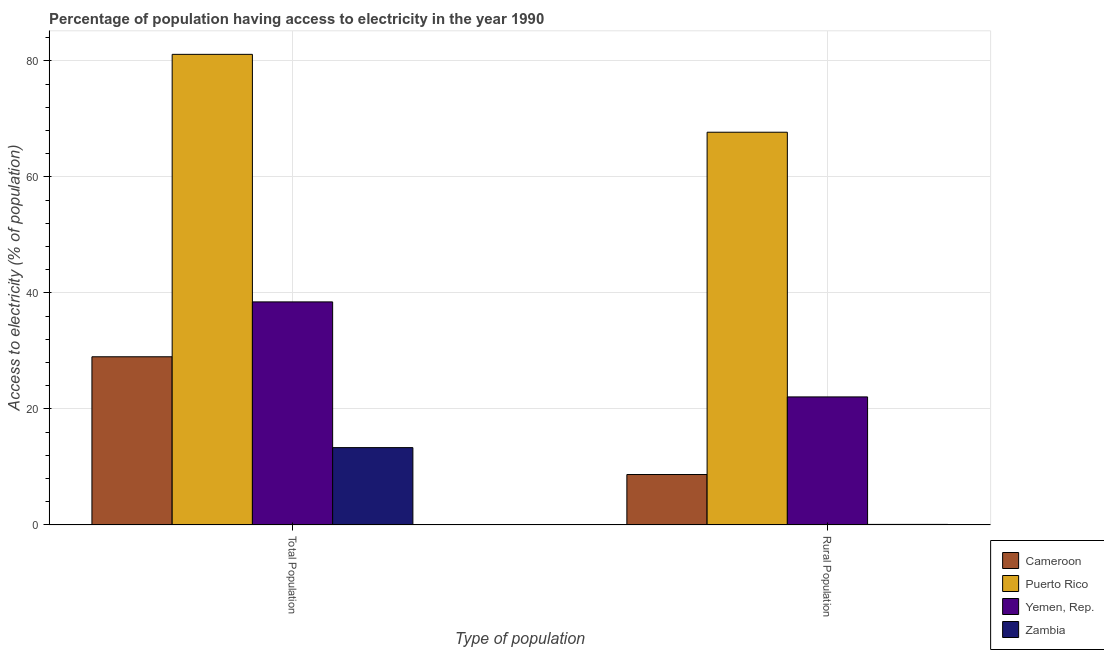Are the number of bars per tick equal to the number of legend labels?
Your response must be concise. Yes. How many bars are there on the 2nd tick from the left?
Offer a terse response. 4. What is the label of the 2nd group of bars from the left?
Offer a very short reply. Rural Population. What is the percentage of rural population having access to electricity in Yemen, Rep.?
Your response must be concise. 22.08. Across all countries, what is the maximum percentage of rural population having access to electricity?
Offer a very short reply. 67.71. Across all countries, what is the minimum percentage of rural population having access to electricity?
Offer a very short reply. 0.1. In which country was the percentage of population having access to electricity maximum?
Keep it short and to the point. Puerto Rico. In which country was the percentage of rural population having access to electricity minimum?
Keep it short and to the point. Zambia. What is the total percentage of rural population having access to electricity in the graph?
Provide a succinct answer. 98.59. What is the difference between the percentage of population having access to electricity in Yemen, Rep. and that in Puerto Rico?
Provide a succinct answer. -42.68. What is the difference between the percentage of population having access to electricity in Cameroon and the percentage of rural population having access to electricity in Puerto Rico?
Your answer should be compact. -38.71. What is the average percentage of rural population having access to electricity per country?
Your answer should be compact. 24.65. What is the difference between the percentage of population having access to electricity and percentage of rural population having access to electricity in Cameroon?
Provide a succinct answer. 20.3. What is the ratio of the percentage of rural population having access to electricity in Puerto Rico to that in Cameroon?
Your answer should be very brief. 7.78. In how many countries, is the percentage of rural population having access to electricity greater than the average percentage of rural population having access to electricity taken over all countries?
Give a very brief answer. 1. What does the 3rd bar from the left in Total Population represents?
Your answer should be compact. Yemen, Rep. What does the 3rd bar from the right in Rural Population represents?
Your answer should be compact. Puerto Rico. Are the values on the major ticks of Y-axis written in scientific E-notation?
Your answer should be very brief. No. Does the graph contain any zero values?
Provide a short and direct response. No. Does the graph contain grids?
Ensure brevity in your answer.  Yes. What is the title of the graph?
Give a very brief answer. Percentage of population having access to electricity in the year 1990. What is the label or title of the X-axis?
Your answer should be very brief. Type of population. What is the label or title of the Y-axis?
Provide a succinct answer. Access to electricity (% of population). What is the Access to electricity (% of population) of Cameroon in Total Population?
Make the answer very short. 29. What is the Access to electricity (% of population) in Puerto Rico in Total Population?
Your response must be concise. 81.14. What is the Access to electricity (% of population) of Yemen, Rep. in Total Population?
Ensure brevity in your answer.  38.46. What is the Access to electricity (% of population) in Zambia in Total Population?
Provide a short and direct response. 13.34. What is the Access to electricity (% of population) in Puerto Rico in Rural Population?
Offer a very short reply. 67.71. What is the Access to electricity (% of population) of Yemen, Rep. in Rural Population?
Your response must be concise. 22.08. Across all Type of population, what is the maximum Access to electricity (% of population) of Puerto Rico?
Your response must be concise. 81.14. Across all Type of population, what is the maximum Access to electricity (% of population) of Yemen, Rep.?
Keep it short and to the point. 38.46. Across all Type of population, what is the maximum Access to electricity (% of population) of Zambia?
Offer a very short reply. 13.34. Across all Type of population, what is the minimum Access to electricity (% of population) in Cameroon?
Provide a short and direct response. 8.7. Across all Type of population, what is the minimum Access to electricity (% of population) of Puerto Rico?
Offer a terse response. 67.71. Across all Type of population, what is the minimum Access to electricity (% of population) in Yemen, Rep.?
Ensure brevity in your answer.  22.08. What is the total Access to electricity (% of population) of Cameroon in the graph?
Provide a short and direct response. 37.7. What is the total Access to electricity (% of population) in Puerto Rico in the graph?
Give a very brief answer. 148.85. What is the total Access to electricity (% of population) of Yemen, Rep. in the graph?
Your answer should be very brief. 60.54. What is the total Access to electricity (% of population) in Zambia in the graph?
Make the answer very short. 13.44. What is the difference between the Access to electricity (% of population) of Cameroon in Total Population and that in Rural Population?
Ensure brevity in your answer.  20.3. What is the difference between the Access to electricity (% of population) in Puerto Rico in Total Population and that in Rural Population?
Offer a very short reply. 13.42. What is the difference between the Access to electricity (% of population) of Yemen, Rep. in Total Population and that in Rural Population?
Ensure brevity in your answer.  16.38. What is the difference between the Access to electricity (% of population) of Zambia in Total Population and that in Rural Population?
Your answer should be compact. 13.24. What is the difference between the Access to electricity (% of population) in Cameroon in Total Population and the Access to electricity (% of population) in Puerto Rico in Rural Population?
Keep it short and to the point. -38.71. What is the difference between the Access to electricity (% of population) in Cameroon in Total Population and the Access to electricity (% of population) in Yemen, Rep. in Rural Population?
Ensure brevity in your answer.  6.92. What is the difference between the Access to electricity (% of population) in Cameroon in Total Population and the Access to electricity (% of population) in Zambia in Rural Population?
Provide a succinct answer. 28.9. What is the difference between the Access to electricity (% of population) in Puerto Rico in Total Population and the Access to electricity (% of population) in Yemen, Rep. in Rural Population?
Provide a short and direct response. 59.06. What is the difference between the Access to electricity (% of population) in Puerto Rico in Total Population and the Access to electricity (% of population) in Zambia in Rural Population?
Provide a short and direct response. 81.04. What is the difference between the Access to electricity (% of population) in Yemen, Rep. in Total Population and the Access to electricity (% of population) in Zambia in Rural Population?
Offer a very short reply. 38.36. What is the average Access to electricity (% of population) in Cameroon per Type of population?
Give a very brief answer. 18.85. What is the average Access to electricity (% of population) in Puerto Rico per Type of population?
Provide a short and direct response. 74.42. What is the average Access to electricity (% of population) in Yemen, Rep. per Type of population?
Provide a succinct answer. 30.27. What is the average Access to electricity (% of population) of Zambia per Type of population?
Provide a short and direct response. 6.72. What is the difference between the Access to electricity (% of population) in Cameroon and Access to electricity (% of population) in Puerto Rico in Total Population?
Ensure brevity in your answer.  -52.14. What is the difference between the Access to electricity (% of population) in Cameroon and Access to electricity (% of population) in Yemen, Rep. in Total Population?
Your response must be concise. -9.46. What is the difference between the Access to electricity (% of population) of Cameroon and Access to electricity (% of population) of Zambia in Total Population?
Provide a short and direct response. 15.66. What is the difference between the Access to electricity (% of population) of Puerto Rico and Access to electricity (% of population) of Yemen, Rep. in Total Population?
Provide a short and direct response. 42.68. What is the difference between the Access to electricity (% of population) in Puerto Rico and Access to electricity (% of population) in Zambia in Total Population?
Make the answer very short. 67.8. What is the difference between the Access to electricity (% of population) in Yemen, Rep. and Access to electricity (% of population) in Zambia in Total Population?
Your answer should be very brief. 25.12. What is the difference between the Access to electricity (% of population) in Cameroon and Access to electricity (% of population) in Puerto Rico in Rural Population?
Ensure brevity in your answer.  -59.01. What is the difference between the Access to electricity (% of population) in Cameroon and Access to electricity (% of population) in Yemen, Rep. in Rural Population?
Your response must be concise. -13.38. What is the difference between the Access to electricity (% of population) in Cameroon and Access to electricity (% of population) in Zambia in Rural Population?
Offer a terse response. 8.6. What is the difference between the Access to electricity (% of population) of Puerto Rico and Access to electricity (% of population) of Yemen, Rep. in Rural Population?
Your answer should be compact. 45.63. What is the difference between the Access to electricity (% of population) in Puerto Rico and Access to electricity (% of population) in Zambia in Rural Population?
Ensure brevity in your answer.  67.61. What is the difference between the Access to electricity (% of population) in Yemen, Rep. and Access to electricity (% of population) in Zambia in Rural Population?
Offer a terse response. 21.98. What is the ratio of the Access to electricity (% of population) of Puerto Rico in Total Population to that in Rural Population?
Provide a succinct answer. 1.2. What is the ratio of the Access to electricity (% of population) in Yemen, Rep. in Total Population to that in Rural Population?
Keep it short and to the point. 1.74. What is the ratio of the Access to electricity (% of population) in Zambia in Total Population to that in Rural Population?
Provide a succinct answer. 133.38. What is the difference between the highest and the second highest Access to electricity (% of population) in Cameroon?
Your answer should be compact. 20.3. What is the difference between the highest and the second highest Access to electricity (% of population) of Puerto Rico?
Ensure brevity in your answer.  13.42. What is the difference between the highest and the second highest Access to electricity (% of population) of Yemen, Rep.?
Your response must be concise. 16.38. What is the difference between the highest and the second highest Access to electricity (% of population) in Zambia?
Your answer should be very brief. 13.24. What is the difference between the highest and the lowest Access to electricity (% of population) in Cameroon?
Your response must be concise. 20.3. What is the difference between the highest and the lowest Access to electricity (% of population) of Puerto Rico?
Provide a succinct answer. 13.42. What is the difference between the highest and the lowest Access to electricity (% of population) in Yemen, Rep.?
Ensure brevity in your answer.  16.38. What is the difference between the highest and the lowest Access to electricity (% of population) in Zambia?
Keep it short and to the point. 13.24. 